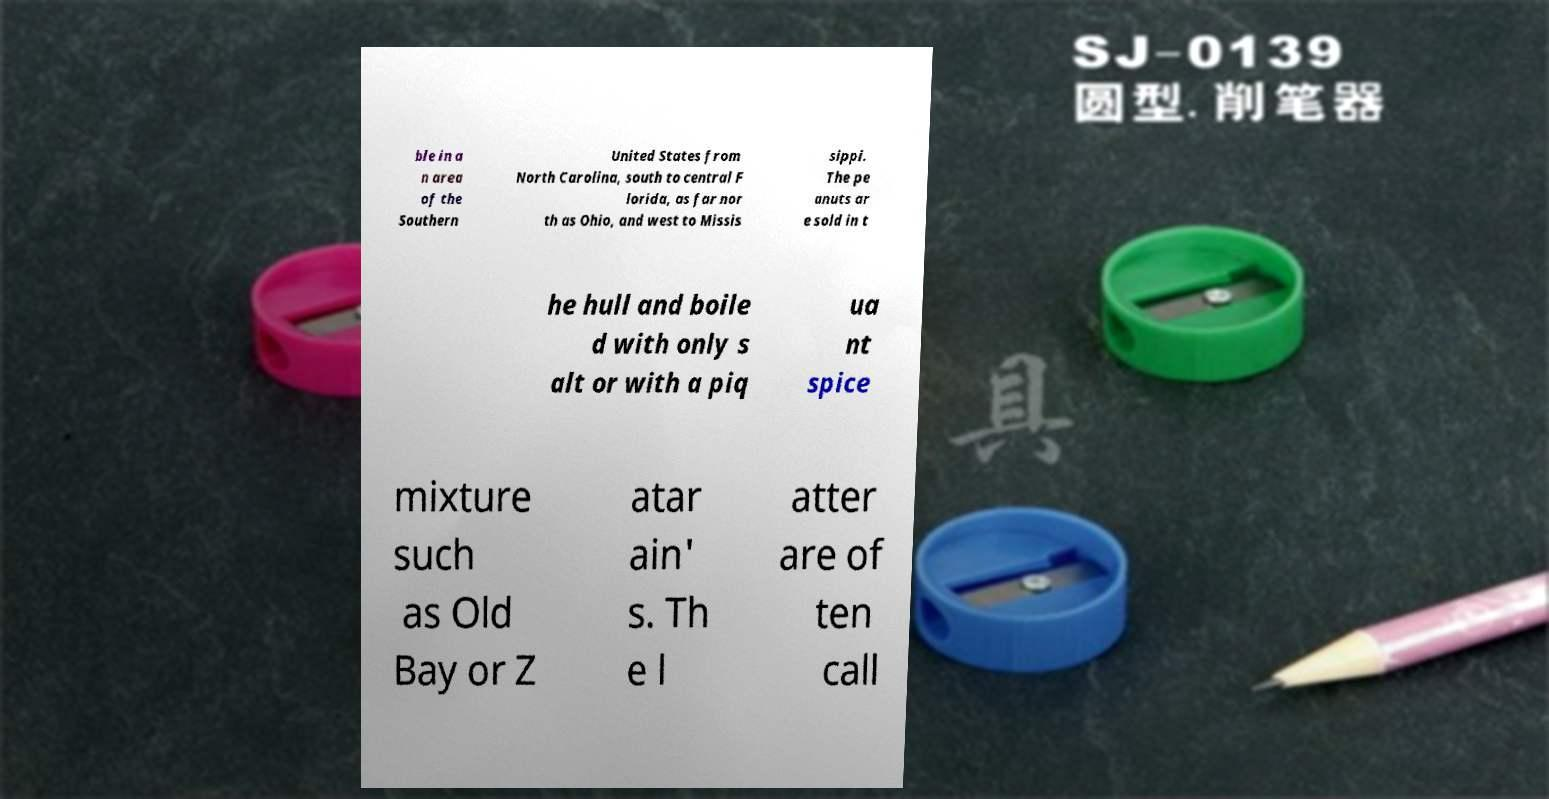Can you read and provide the text displayed in the image?This photo seems to have some interesting text. Can you extract and type it out for me? ble in a n area of the Southern United States from North Carolina, south to central F lorida, as far nor th as Ohio, and west to Missis sippi. The pe anuts ar e sold in t he hull and boile d with only s alt or with a piq ua nt spice mixture such as Old Bay or Z atar ain' s. Th e l atter are of ten call 